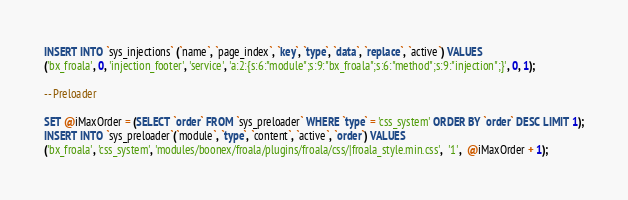Convert code to text. <code><loc_0><loc_0><loc_500><loc_500><_SQL_>INSERT INTO `sys_injections` (`name`, `page_index`, `key`, `type`, `data`, `replace`, `active`) VALUES
('bx_froala', 0, 'injection_footer', 'service', 'a:2:{s:6:"module";s:9:"bx_froala";s:6:"method";s:9:"injection";}', 0, 1);

-- Preloader

SET @iMaxOrder = (SELECT `order` FROM `sys_preloader` WHERE `type` = 'css_system' ORDER BY `order` DESC LIMIT 1);
INSERT INTO `sys_preloader`(`module`, `type`, `content`, `active`, `order`) VALUES
('bx_froala', 'css_system', 'modules/boonex/froala/plugins/froala/css/|froala_style.min.css',  '1',  @iMaxOrder + 1);
</code> 